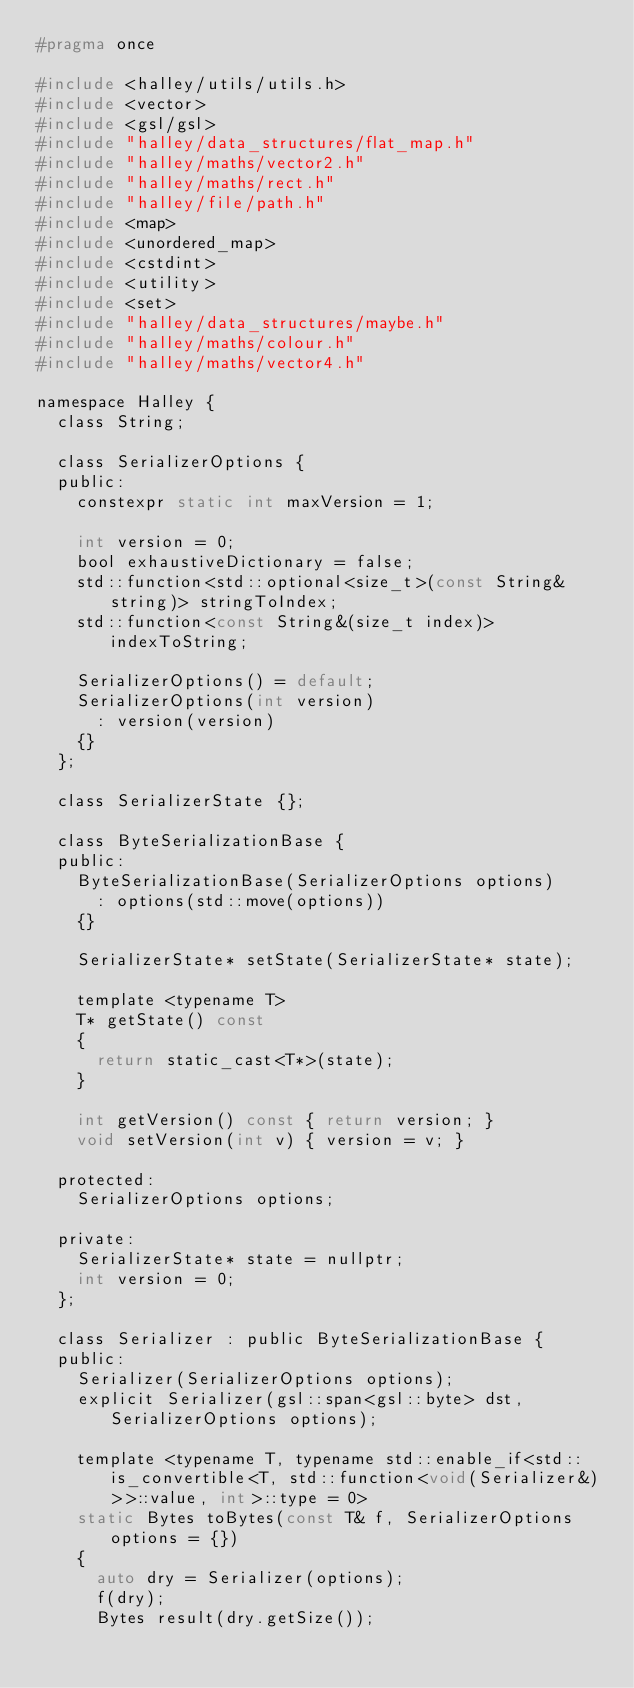<code> <loc_0><loc_0><loc_500><loc_500><_C_>#pragma once

#include <halley/utils/utils.h>
#include <vector>
#include <gsl/gsl>
#include "halley/data_structures/flat_map.h"
#include "halley/maths/vector2.h"
#include "halley/maths/rect.h"
#include "halley/file/path.h"
#include <map>
#include <unordered_map>
#include <cstdint>
#include <utility>
#include <set>
#include "halley/data_structures/maybe.h"
#include "halley/maths/colour.h"
#include "halley/maths/vector4.h"

namespace Halley {
	class String;

	class SerializerOptions {
	public:
		constexpr static int maxVersion = 1;
		
		int version = 0;
		bool exhaustiveDictionary = false;
		std::function<std::optional<size_t>(const String& string)> stringToIndex;
		std::function<const String&(size_t index)> indexToString;

		SerializerOptions() = default;
		SerializerOptions(int version)
			: version(version)
		{}
	};

	class SerializerState {};

	class ByteSerializationBase {
	public:
		ByteSerializationBase(SerializerOptions options)
			: options(std::move(options))
		{}
		
		SerializerState* setState(SerializerState* state);
		
		template <typename T>
		T* getState() const
		{
			return static_cast<T*>(state);
		}

		int getVersion() const { return version; }
		void setVersion(int v) { version = v; }

	protected:
		SerializerOptions options;
		
	private:
		SerializerState* state = nullptr;
		int version = 0;
	};
		
	class Serializer : public ByteSerializationBase {
	public:
		Serializer(SerializerOptions options);
		explicit Serializer(gsl::span<gsl::byte> dst, SerializerOptions options);

		template <typename T, typename std::enable_if<std::is_convertible<T, std::function<void(Serializer&)>>::value, int>::type = 0>
		static Bytes toBytes(const T& f, SerializerOptions options = {})
		{
			auto dry = Serializer(options);
			f(dry);
			Bytes result(dry.getSize());</code> 